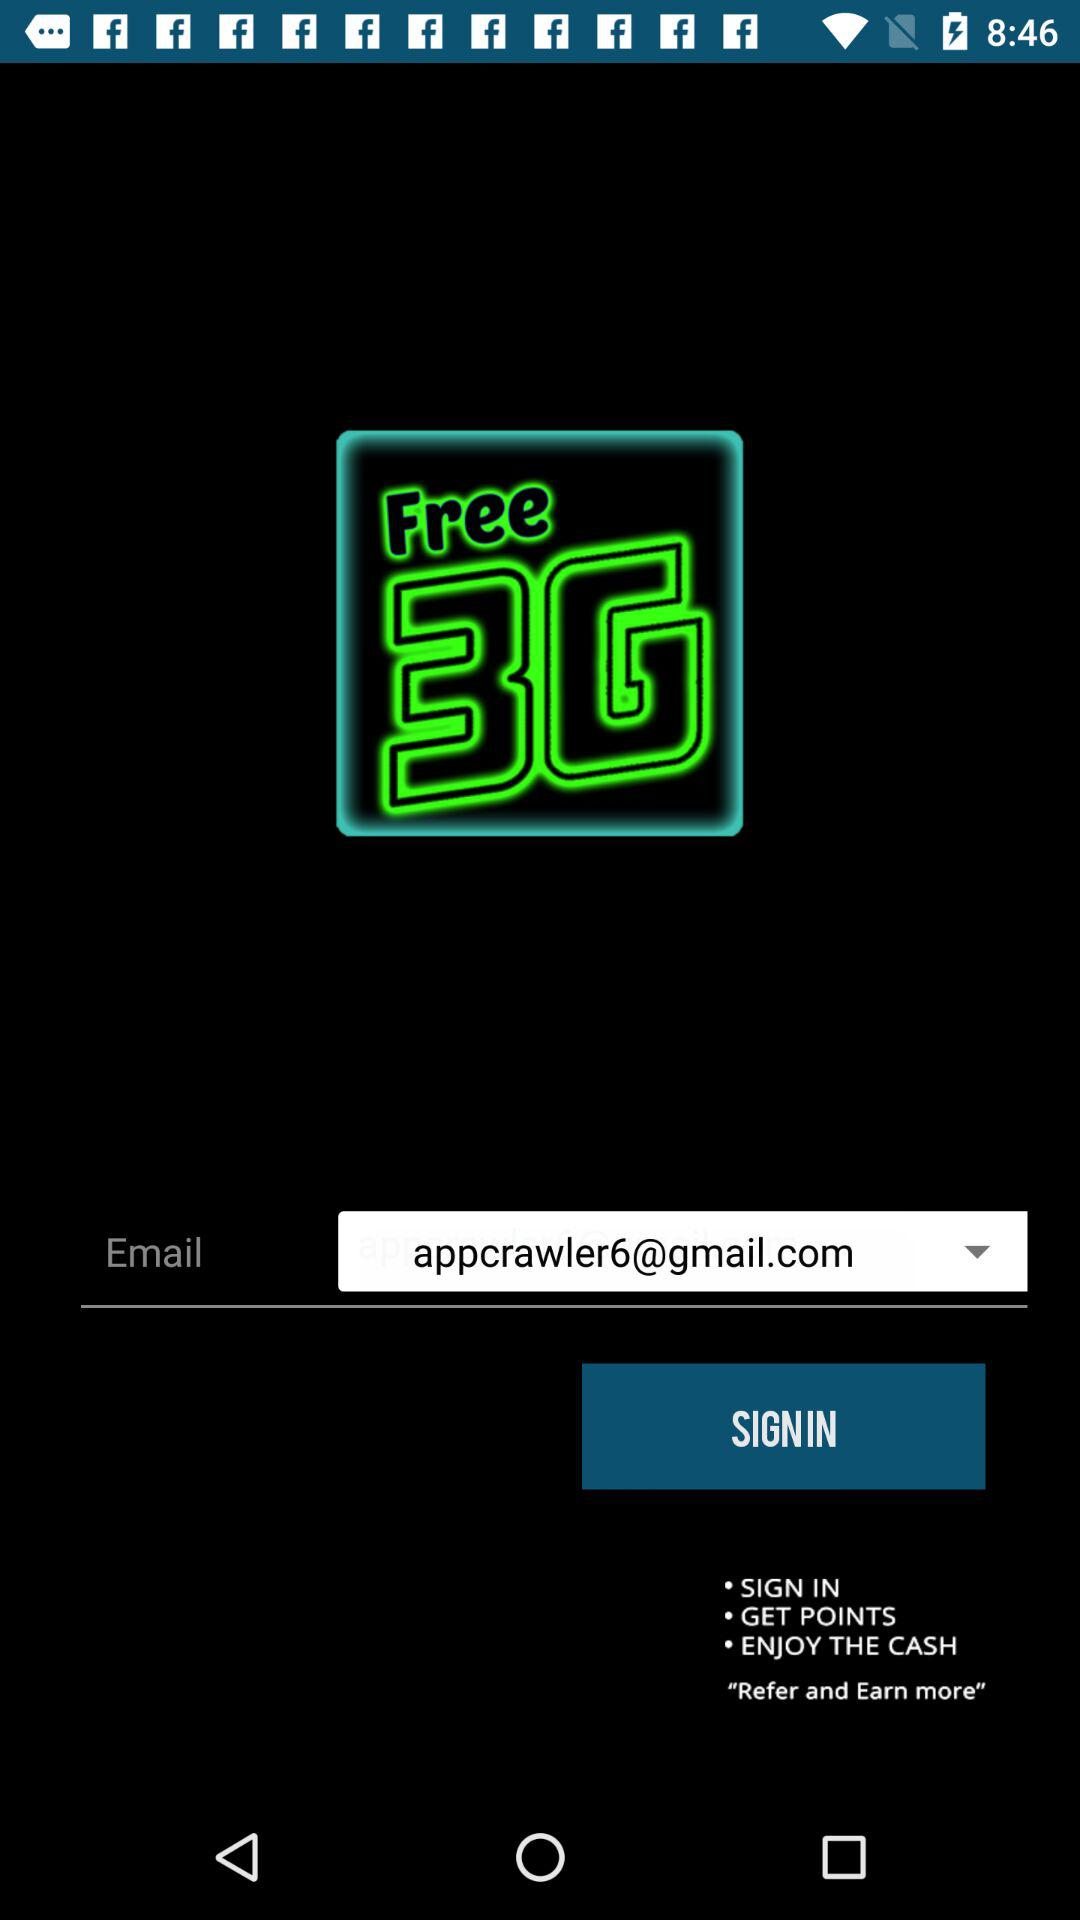What is the email address? The email address is appcrawler6@gmail.com. 